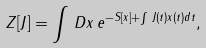<formula> <loc_0><loc_0><loc_500><loc_500>Z [ J ] = \int \, D x \, e ^ { - S [ x ] + \int \, J ( t ) x ( t ) d t } ,</formula> 